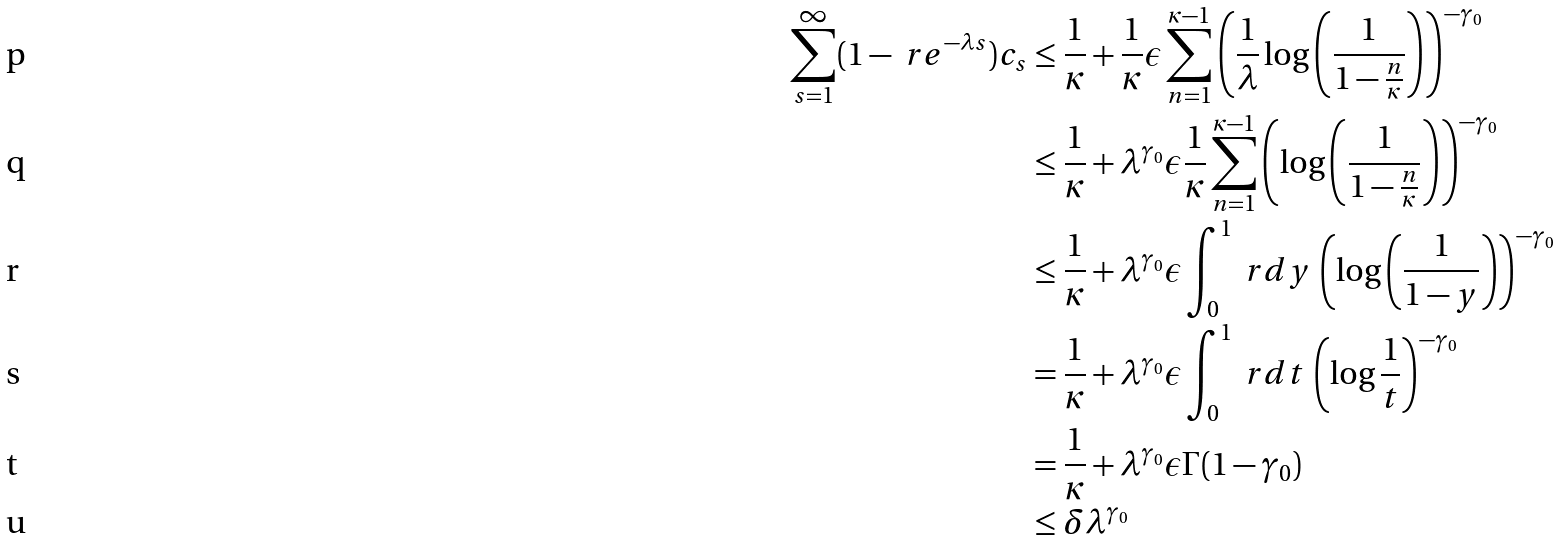<formula> <loc_0><loc_0><loc_500><loc_500>\sum _ { s = 1 } ^ { \infty } ( 1 - \ r e ^ { - \lambda s } ) c _ { s } & \leq \frac { 1 } { \kappa } + \frac { 1 } { \kappa } \epsilon \sum _ { n = 1 } ^ { \kappa - 1 } \left ( \frac { 1 } { \lambda } \log \left ( \frac { 1 } { 1 - \frac { n } { \kappa } } \right ) \right ) ^ { - \gamma _ { 0 } } \\ & \leq \frac { 1 } { \kappa } + \lambda ^ { \gamma _ { 0 } } \epsilon \frac { 1 } { \kappa } \sum _ { n = 1 } ^ { \kappa - 1 } \left ( \log \left ( \frac { 1 } { 1 - \frac { n } { \kappa } } \right ) \right ) ^ { - \gamma _ { 0 } } \\ & \leq \frac { 1 } { \kappa } + \lambda ^ { \gamma _ { 0 } } \epsilon \int _ { 0 } ^ { 1 } \ r d y \, \left ( \log \left ( \frac { 1 } { 1 - y } \right ) \right ) ^ { - \gamma _ { 0 } } \\ & = \frac { 1 } { \kappa } + \lambda ^ { \gamma _ { 0 } } \epsilon \int _ { 0 } ^ { 1 } \ r d t \, \left ( \log \frac { 1 } { t } \right ) ^ { - \gamma _ { 0 } } \\ & = \frac { 1 } { \kappa } + \lambda ^ { \gamma _ { 0 } } \epsilon \Gamma ( 1 - \gamma _ { 0 } ) \\ & \leq \delta \lambda ^ { \gamma _ { 0 } }</formula> 